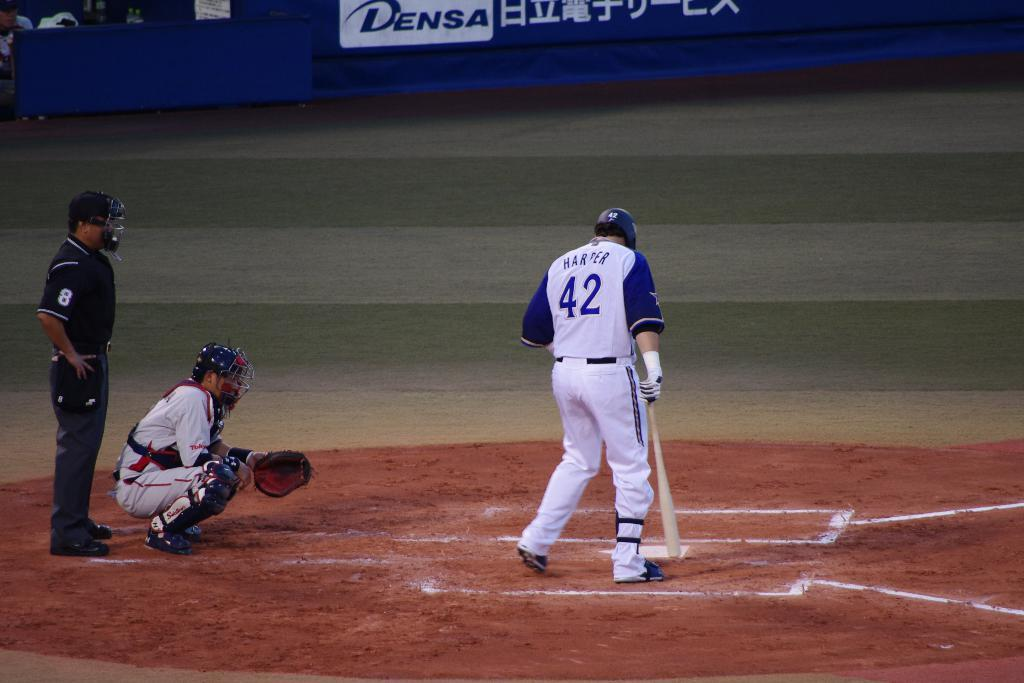Provide a one-sentence caption for the provided image. Batter wearing the number 42 looking down at the ground. 